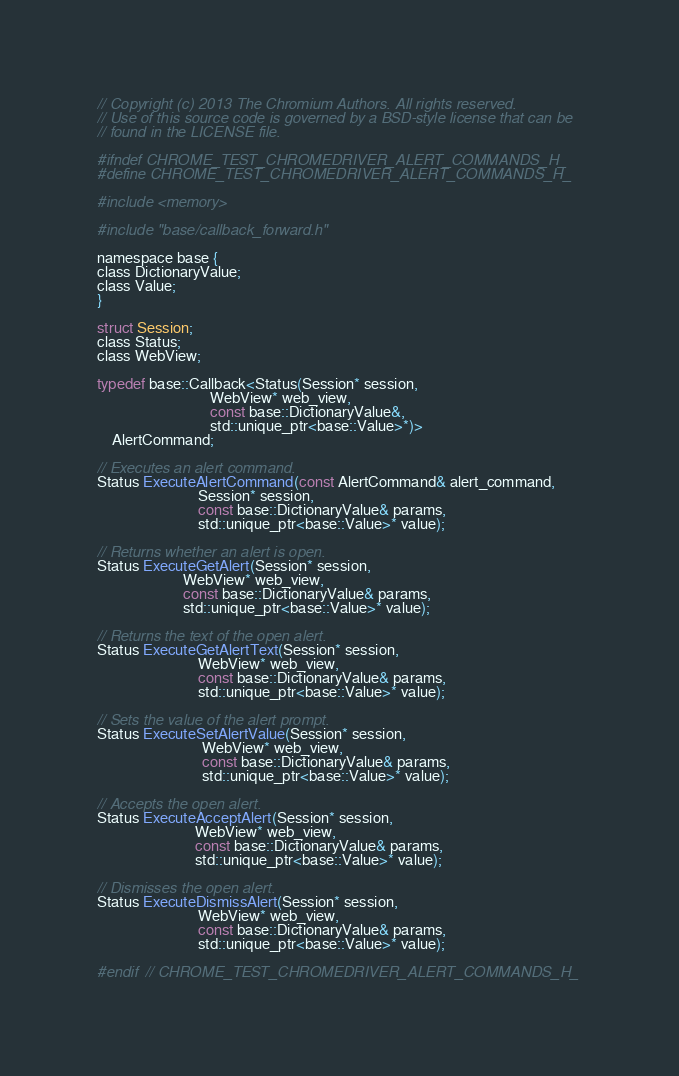Convert code to text. <code><loc_0><loc_0><loc_500><loc_500><_C_>// Copyright (c) 2013 The Chromium Authors. All rights reserved.
// Use of this source code is governed by a BSD-style license that can be
// found in the LICENSE file.

#ifndef CHROME_TEST_CHROMEDRIVER_ALERT_COMMANDS_H_
#define CHROME_TEST_CHROMEDRIVER_ALERT_COMMANDS_H_

#include <memory>

#include "base/callback_forward.h"

namespace base {
class DictionaryValue;
class Value;
}

struct Session;
class Status;
class WebView;

typedef base::Callback<Status(Session* session,
                              WebView* web_view,
                              const base::DictionaryValue&,
                              std::unique_ptr<base::Value>*)>
    AlertCommand;

// Executes an alert command.
Status ExecuteAlertCommand(const AlertCommand& alert_command,
                           Session* session,
                           const base::DictionaryValue& params,
                           std::unique_ptr<base::Value>* value);

// Returns whether an alert is open.
Status ExecuteGetAlert(Session* session,
                       WebView* web_view,
                       const base::DictionaryValue& params,
                       std::unique_ptr<base::Value>* value);

// Returns the text of the open alert.
Status ExecuteGetAlertText(Session* session,
                           WebView* web_view,
                           const base::DictionaryValue& params,
                           std::unique_ptr<base::Value>* value);

// Sets the value of the alert prompt.
Status ExecuteSetAlertValue(Session* session,
                            WebView* web_view,
                            const base::DictionaryValue& params,
                            std::unique_ptr<base::Value>* value);

// Accepts the open alert.
Status ExecuteAcceptAlert(Session* session,
                          WebView* web_view,
                          const base::DictionaryValue& params,
                          std::unique_ptr<base::Value>* value);

// Dismisses the open alert.
Status ExecuteDismissAlert(Session* session,
                           WebView* web_view,
                           const base::DictionaryValue& params,
                           std::unique_ptr<base::Value>* value);

#endif  // CHROME_TEST_CHROMEDRIVER_ALERT_COMMANDS_H_
</code> 